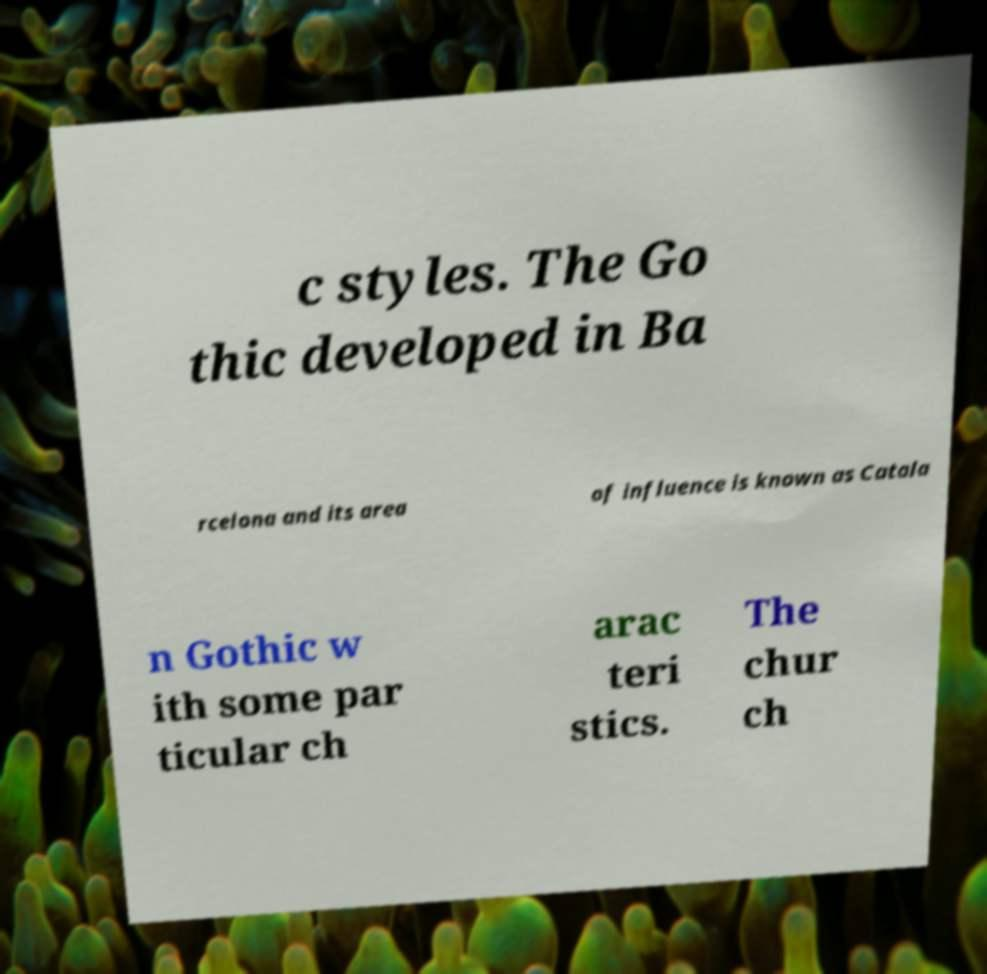Can you accurately transcribe the text from the provided image for me? c styles. The Go thic developed in Ba rcelona and its area of influence is known as Catala n Gothic w ith some par ticular ch arac teri stics. The chur ch 